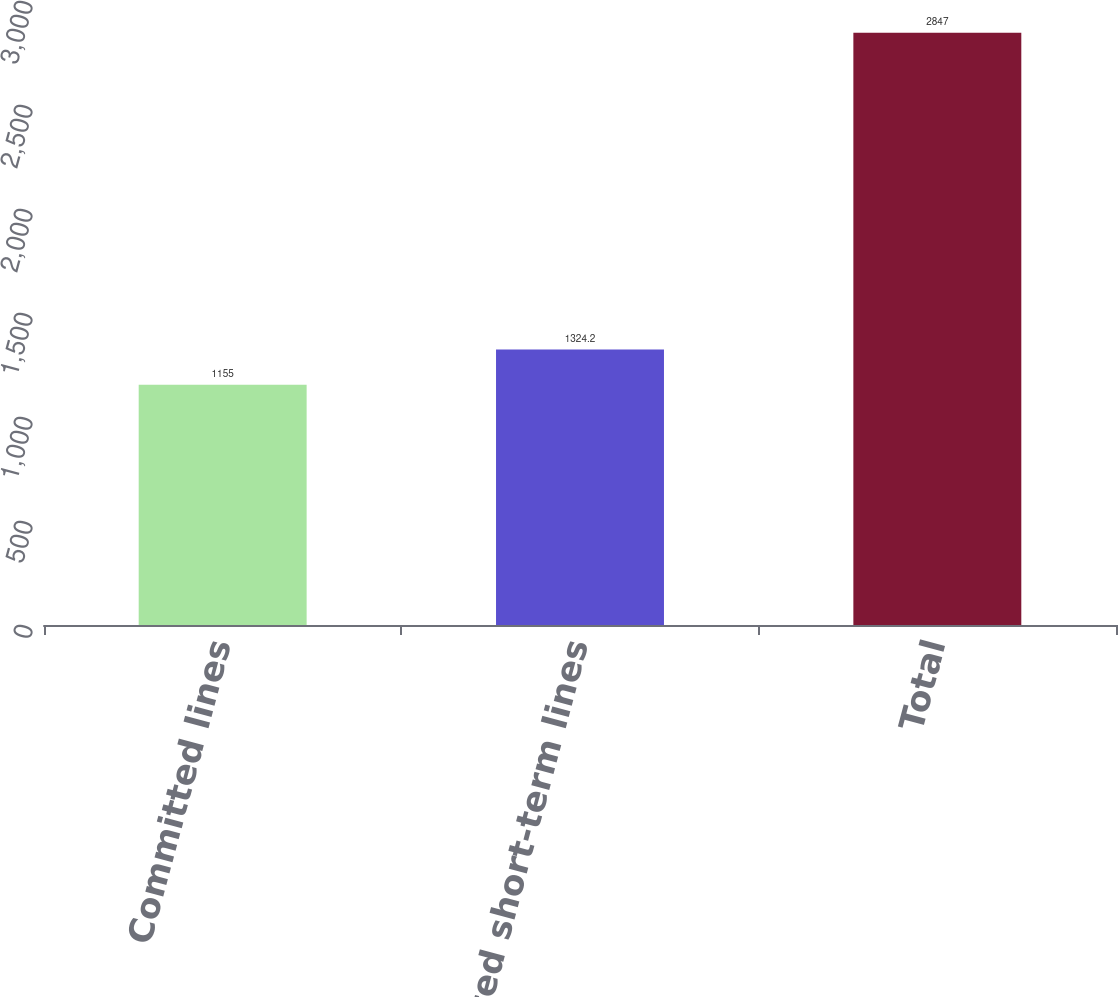<chart> <loc_0><loc_0><loc_500><loc_500><bar_chart><fcel>Committed lines<fcel>Uncommitted short-term lines<fcel>Total<nl><fcel>1155<fcel>1324.2<fcel>2847<nl></chart> 